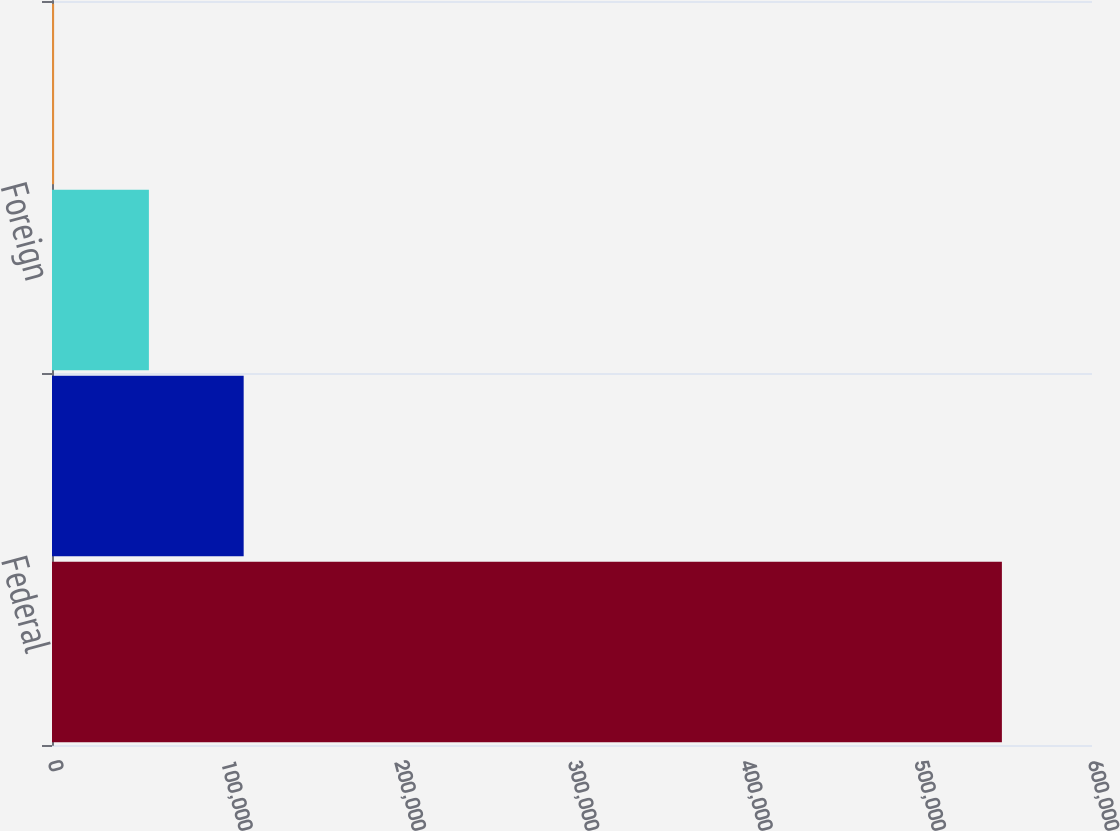Convert chart to OTSL. <chart><loc_0><loc_0><loc_500><loc_500><bar_chart><fcel>Federal<fcel>State<fcel>Foreign<fcel>Valuation allowance<nl><fcel>548018<fcel>110580<fcel>55899.8<fcel>1220<nl></chart> 